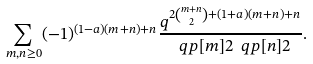Convert formula to latex. <formula><loc_0><loc_0><loc_500><loc_500>\sum _ { m , n \geq 0 } ( - 1 ) ^ { ( 1 - a ) ( m + n ) + n } \frac { q ^ { 2 \binom { m + n } { 2 } + ( 1 + a ) ( m + n ) + n } } { \ q p [ m ] { 2 } \ q p [ n ] { 2 } } .</formula> 